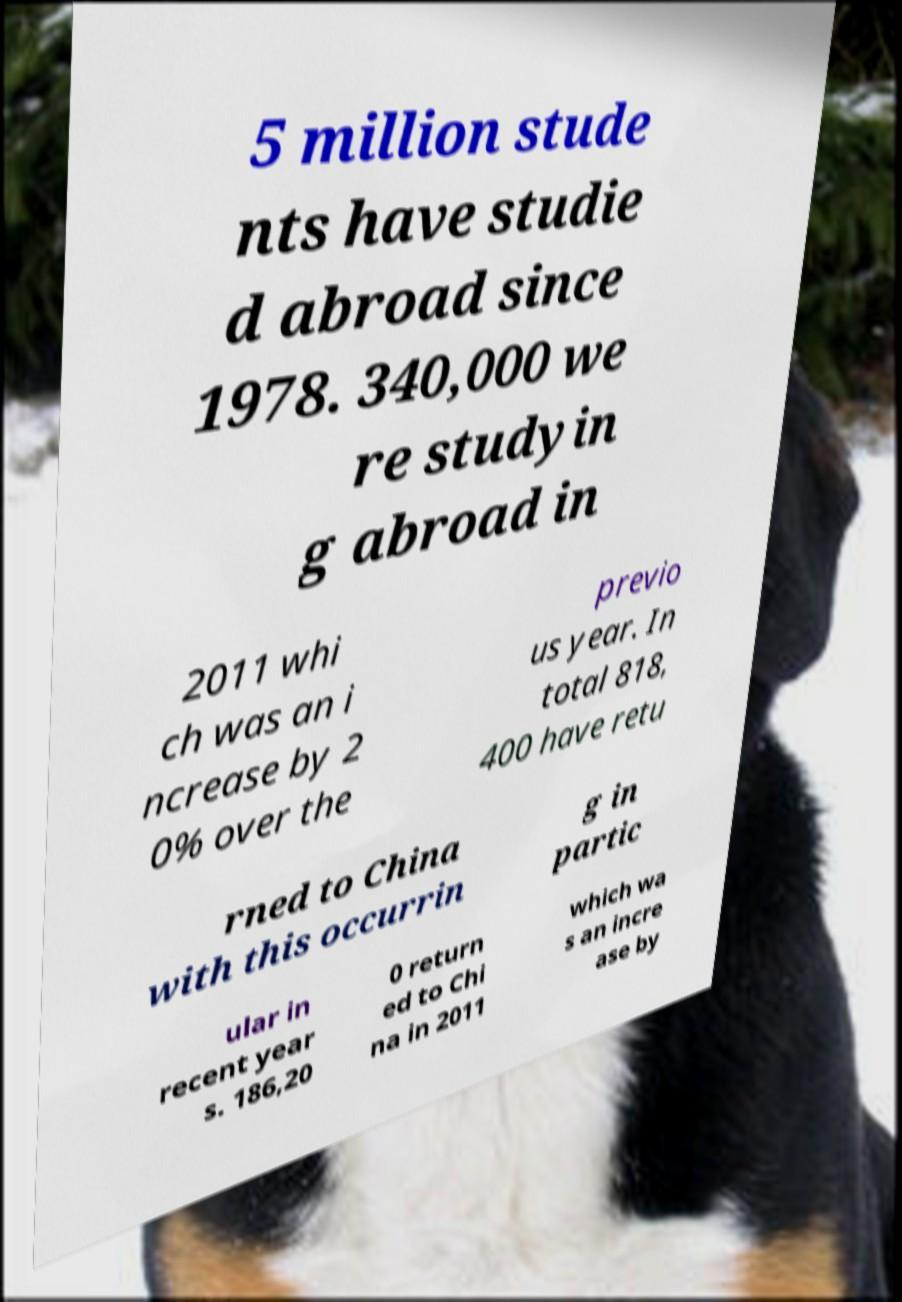What messages or text are displayed in this image? I need them in a readable, typed format. 5 million stude nts have studie d abroad since 1978. 340,000 we re studyin g abroad in 2011 whi ch was an i ncrease by 2 0% over the previo us year. In total 818, 400 have retu rned to China with this occurrin g in partic ular in recent year s. 186,20 0 return ed to Chi na in 2011 which wa s an incre ase by 